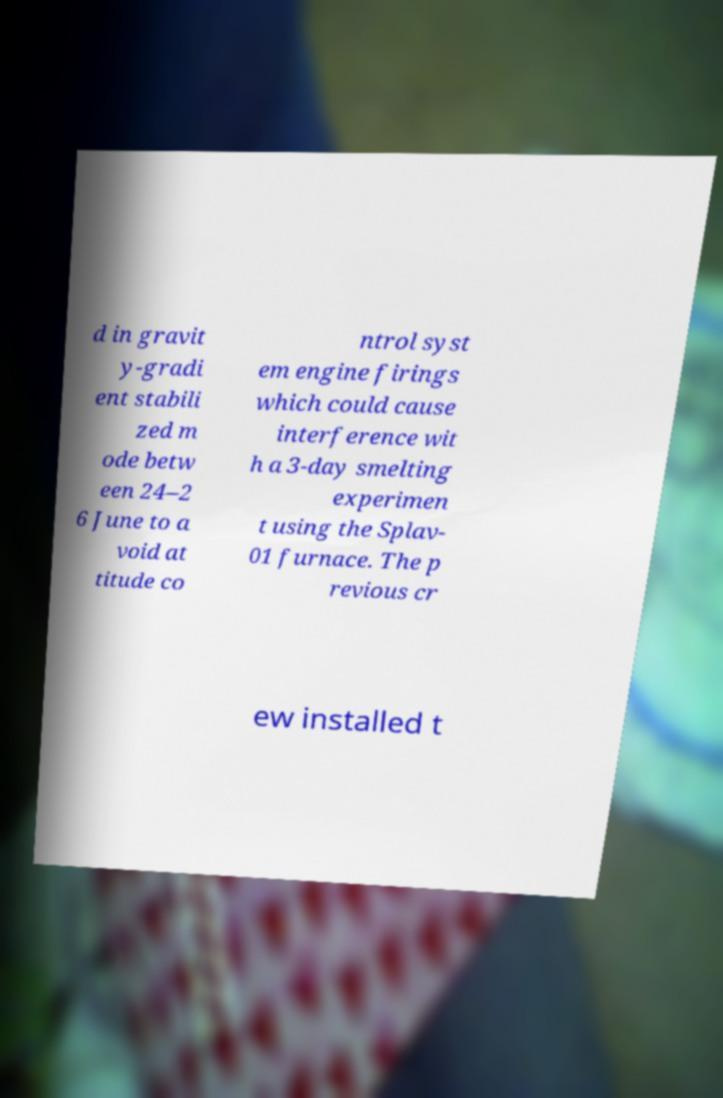Could you extract and type out the text from this image? d in gravit y-gradi ent stabili zed m ode betw een 24–2 6 June to a void at titude co ntrol syst em engine firings which could cause interference wit h a 3-day smelting experimen t using the Splav- 01 furnace. The p revious cr ew installed t 